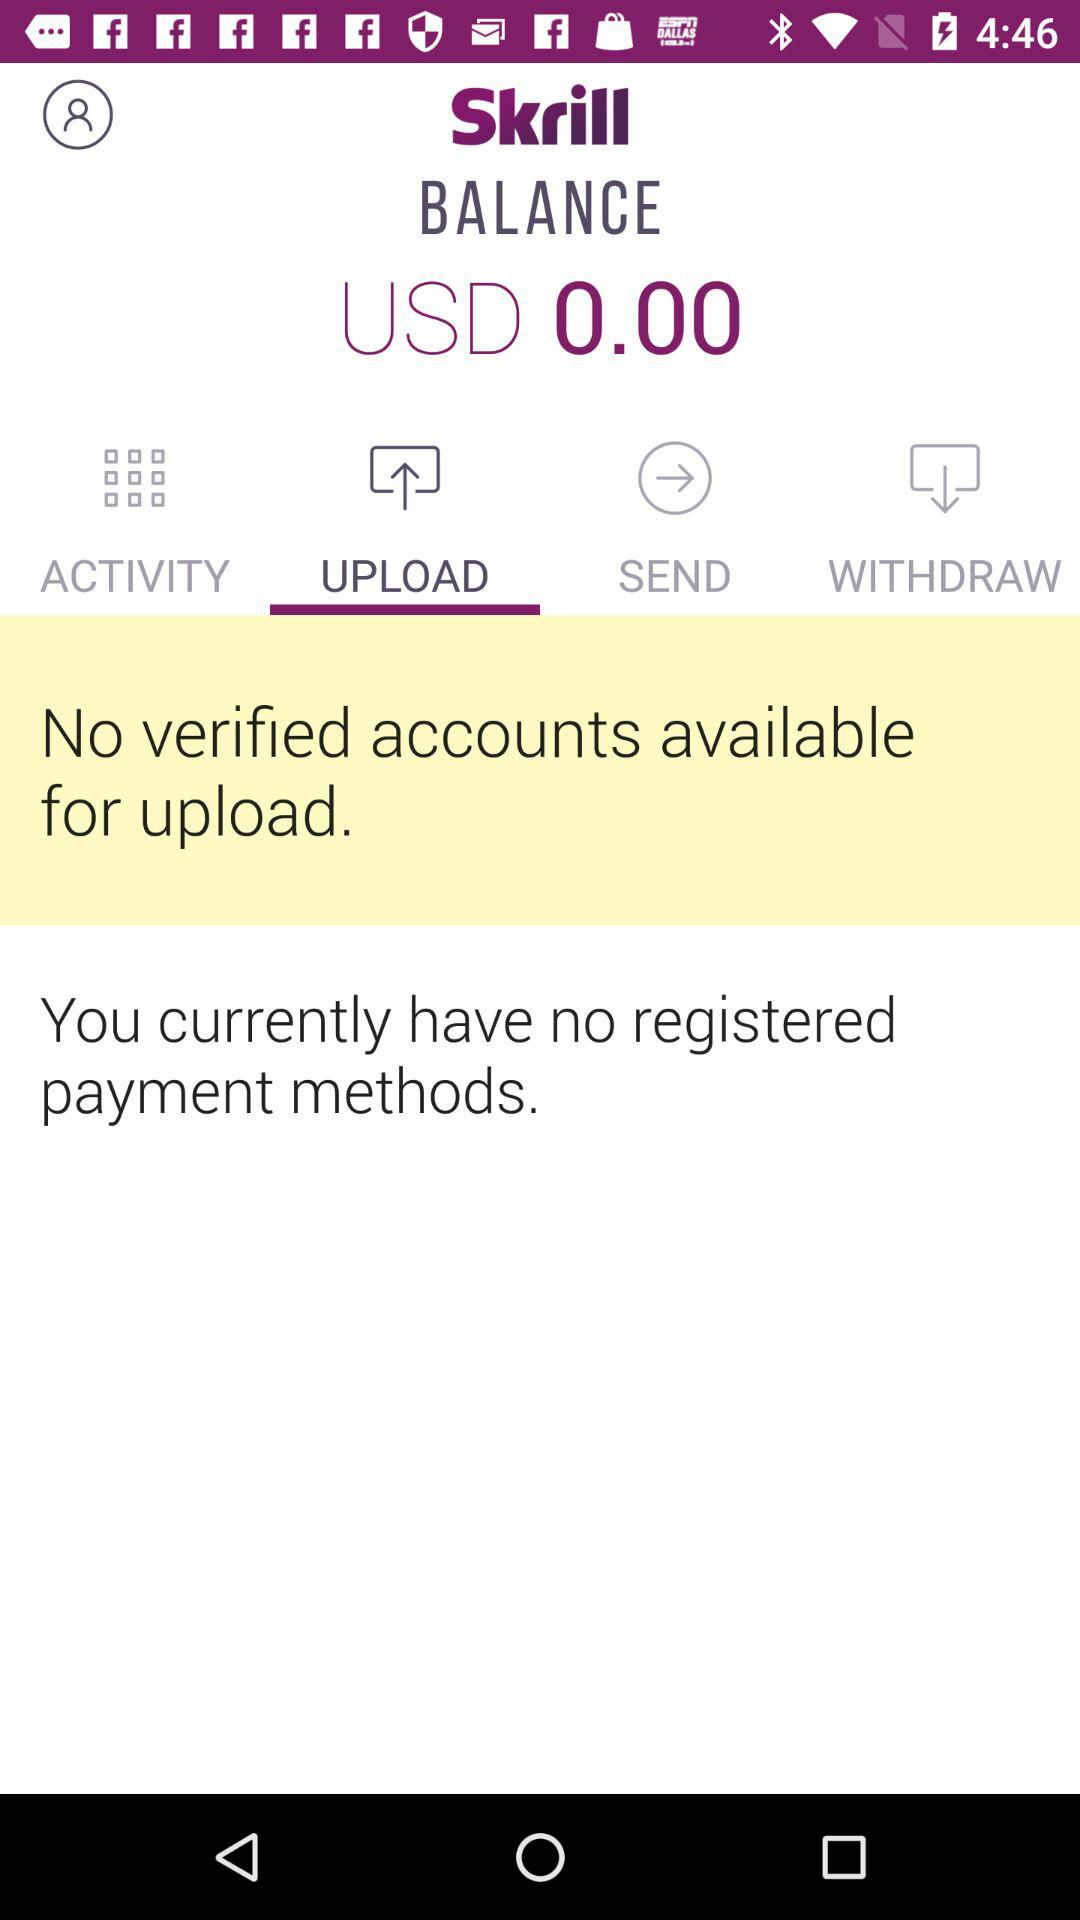Which tab is selected? The selected tab is "UPLOAD". 